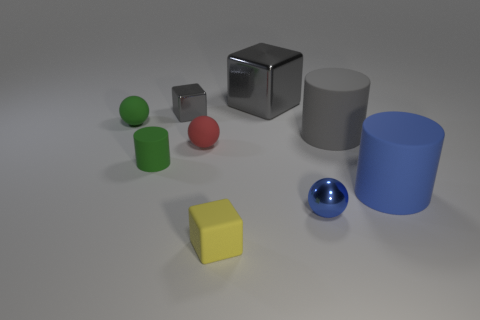Add 1 tiny blue shiny objects. How many objects exist? 10 Subtract all blue rubber cylinders. How many cylinders are left? 2 Subtract 0 brown balls. How many objects are left? 9 Subtract all cylinders. How many objects are left? 6 Subtract 1 cylinders. How many cylinders are left? 2 Subtract all yellow cubes. Subtract all yellow spheres. How many cubes are left? 2 Subtract all brown cylinders. How many yellow cubes are left? 1 Subtract all big blue matte objects. Subtract all big blue things. How many objects are left? 7 Add 5 blue shiny balls. How many blue shiny balls are left? 6 Add 8 large cubes. How many large cubes exist? 9 